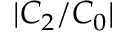Convert formula to latex. <formula><loc_0><loc_0><loc_500><loc_500>| C _ { 2 } / C _ { 0 } |</formula> 